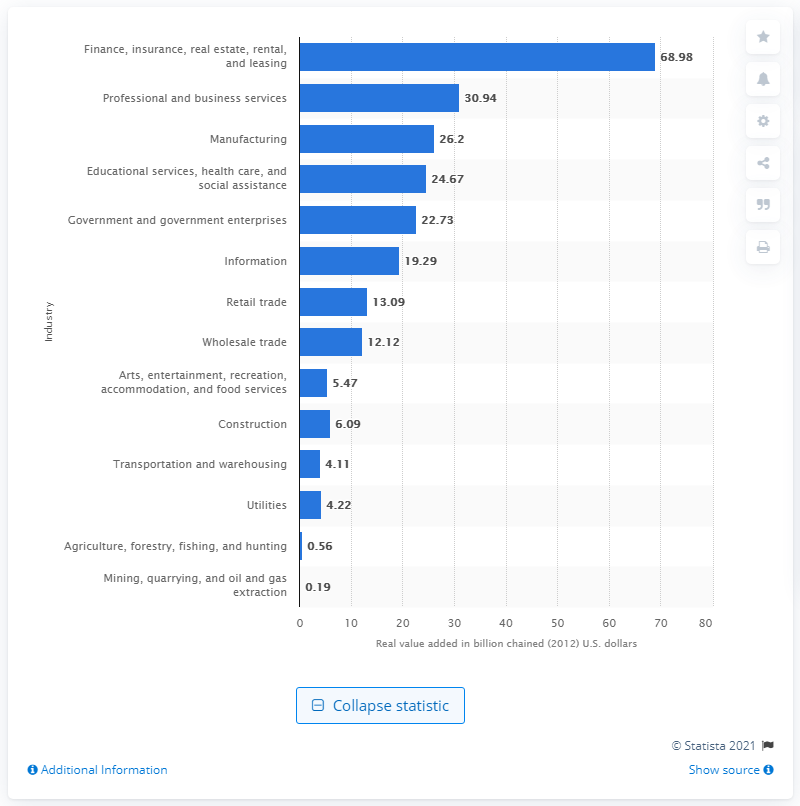Which industry contributes the least to Connecticut's GDP according to the chart? Mining, quarrying, and oil and gas extraction industry contribute the least to Connecticut's GDP, with a value of $0.19 billion. 